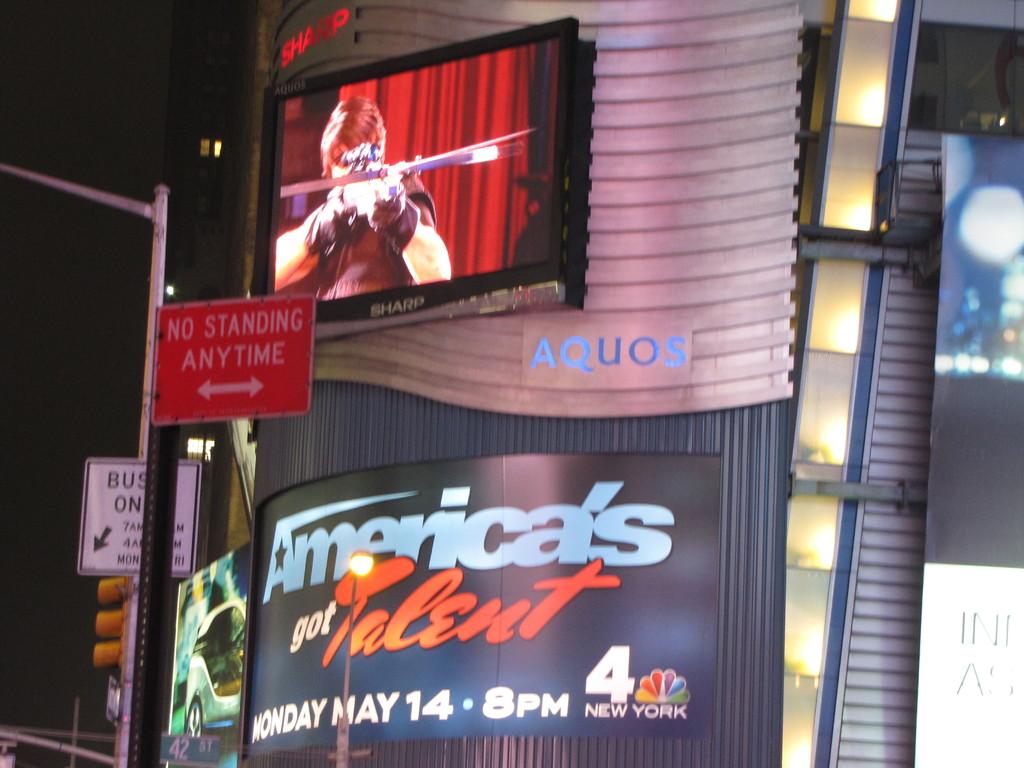What time is the show?
Offer a very short reply. 8pm. Where state is under the logo?
Keep it short and to the point. New york. 